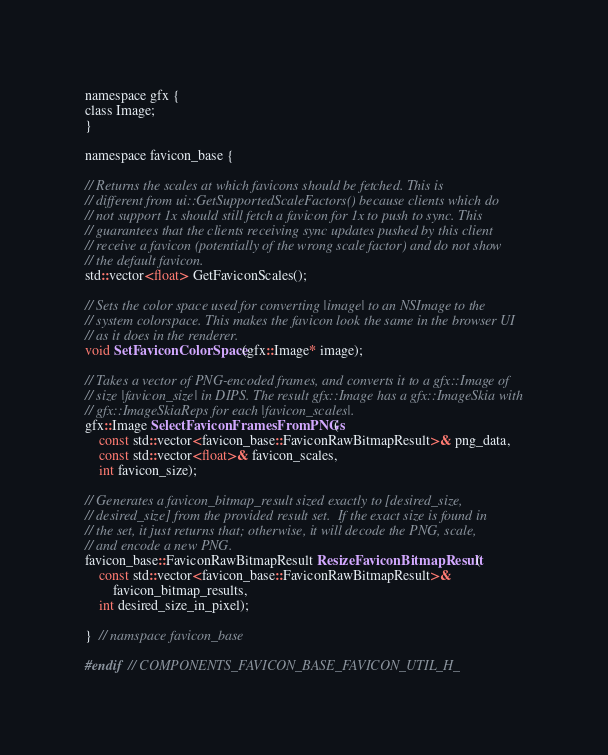<code> <loc_0><loc_0><loc_500><loc_500><_C_>
namespace gfx {
class Image;
}

namespace favicon_base {

// Returns the scales at which favicons should be fetched. This is
// different from ui::GetSupportedScaleFactors() because clients which do
// not support 1x should still fetch a favicon for 1x to push to sync. This
// guarantees that the clients receiving sync updates pushed by this client
// receive a favicon (potentially of the wrong scale factor) and do not show
// the default favicon.
std::vector<float> GetFaviconScales();

// Sets the color space used for converting |image| to an NSImage to the
// system colorspace. This makes the favicon look the same in the browser UI
// as it does in the renderer.
void SetFaviconColorSpace(gfx::Image* image);

// Takes a vector of PNG-encoded frames, and converts it to a gfx::Image of
// size |favicon_size| in DIPS. The result gfx::Image has a gfx::ImageSkia with
// gfx::ImageSkiaReps for each |favicon_scales|.
gfx::Image SelectFaviconFramesFromPNGs(
    const std::vector<favicon_base::FaviconRawBitmapResult>& png_data,
    const std::vector<float>& favicon_scales,
    int favicon_size);

// Generates a favicon_bitmap_result sized exactly to [desired_size,
// desired_size] from the provided result set.  If the exact size is found in
// the set, it just returns that; otherwise, it will decode the PNG, scale,
// and encode a new PNG.
favicon_base::FaviconRawBitmapResult ResizeFaviconBitmapResult(
    const std::vector<favicon_base::FaviconRawBitmapResult>&
        favicon_bitmap_results,
    int desired_size_in_pixel);

}  // namspace favicon_base

#endif  // COMPONENTS_FAVICON_BASE_FAVICON_UTIL_H_
</code> 